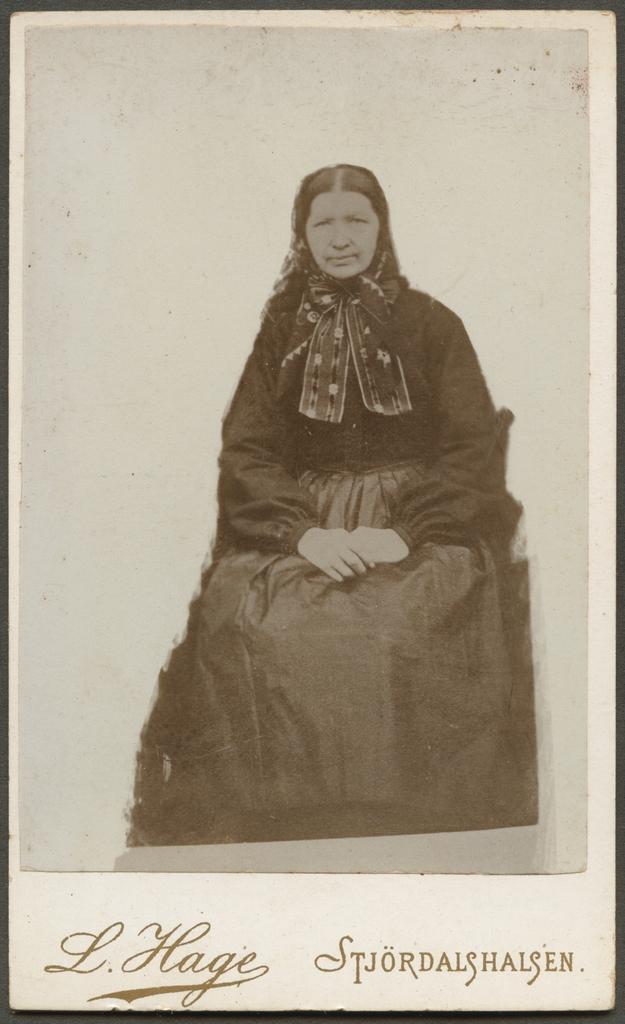In one or two sentences, can you explain what this image depicts? This image is a photograph. In this image we can see woman sitting. At the bottom there is a text. 